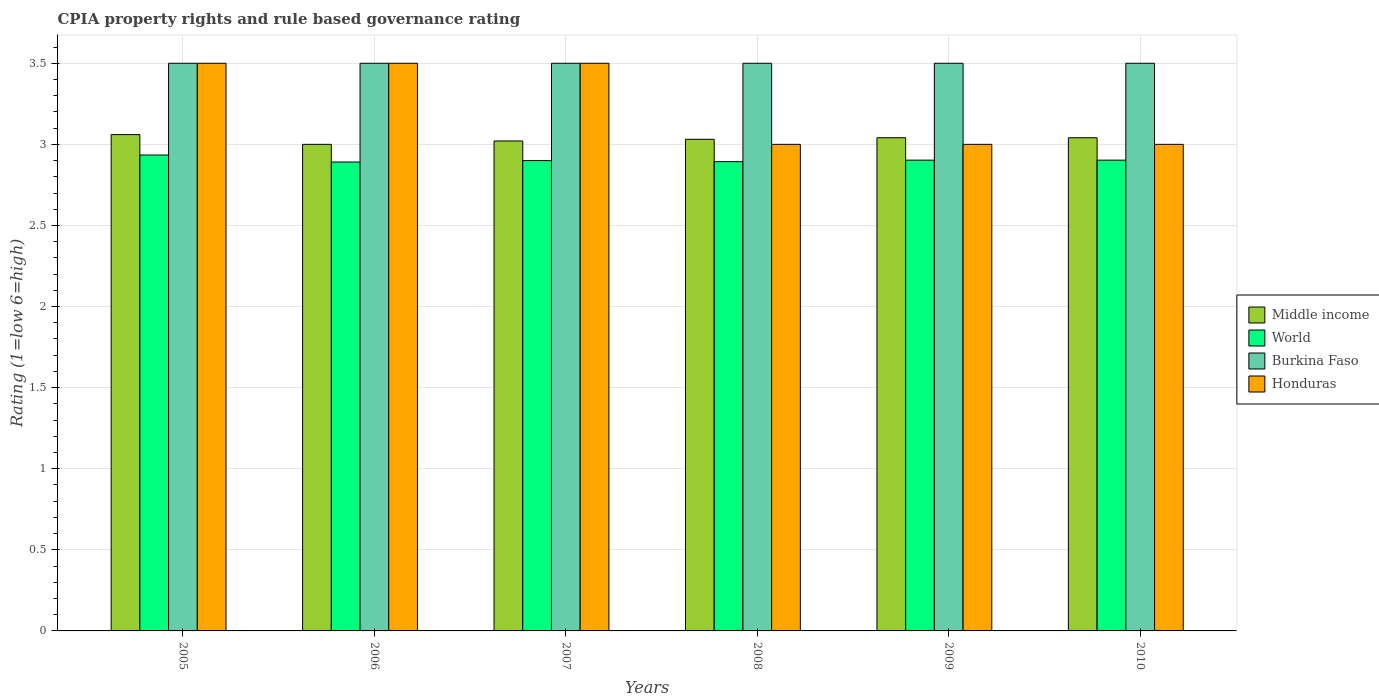How many different coloured bars are there?
Give a very brief answer. 4. Are the number of bars per tick equal to the number of legend labels?
Your answer should be compact. Yes. Are the number of bars on each tick of the X-axis equal?
Your answer should be very brief. Yes. How many bars are there on the 6th tick from the left?
Keep it short and to the point. 4. What is the total CPIA rating in World in the graph?
Your answer should be compact. 17.42. What is the difference between the CPIA rating in Middle income in 2008 and that in 2010?
Offer a very short reply. -0.01. What is the difference between the CPIA rating in Middle income in 2008 and the CPIA rating in Honduras in 2006?
Keep it short and to the point. -0.47. In the year 2009, what is the difference between the CPIA rating in Honduras and CPIA rating in World?
Keep it short and to the point. 0.1. Is the difference between the CPIA rating in Honduras in 2007 and 2008 greater than the difference between the CPIA rating in World in 2007 and 2008?
Provide a short and direct response. Yes. What is the difference between the highest and the second highest CPIA rating in World?
Your response must be concise. 0.03. Is the sum of the CPIA rating in Burkina Faso in 2006 and 2009 greater than the maximum CPIA rating in World across all years?
Provide a succinct answer. Yes. Is it the case that in every year, the sum of the CPIA rating in Honduras and CPIA rating in Burkina Faso is greater than the sum of CPIA rating in World and CPIA rating in Middle income?
Keep it short and to the point. Yes. What does the 3rd bar from the left in 2010 represents?
Your answer should be very brief. Burkina Faso. How many years are there in the graph?
Provide a succinct answer. 6. What is the difference between two consecutive major ticks on the Y-axis?
Ensure brevity in your answer.  0.5. Are the values on the major ticks of Y-axis written in scientific E-notation?
Offer a terse response. No. Where does the legend appear in the graph?
Give a very brief answer. Center right. How many legend labels are there?
Your answer should be compact. 4. What is the title of the graph?
Provide a short and direct response. CPIA property rights and rule based governance rating. What is the Rating (1=low 6=high) of Middle income in 2005?
Provide a short and direct response. 3.06. What is the Rating (1=low 6=high) of World in 2005?
Your answer should be compact. 2.93. What is the Rating (1=low 6=high) in World in 2006?
Give a very brief answer. 2.89. What is the Rating (1=low 6=high) in Burkina Faso in 2006?
Provide a succinct answer. 3.5. What is the Rating (1=low 6=high) in Honduras in 2006?
Keep it short and to the point. 3.5. What is the Rating (1=low 6=high) of Middle income in 2007?
Your response must be concise. 3.02. What is the Rating (1=low 6=high) of World in 2007?
Offer a very short reply. 2.9. What is the Rating (1=low 6=high) of Honduras in 2007?
Provide a succinct answer. 3.5. What is the Rating (1=low 6=high) of Middle income in 2008?
Your answer should be very brief. 3.03. What is the Rating (1=low 6=high) of World in 2008?
Ensure brevity in your answer.  2.89. What is the Rating (1=low 6=high) of Burkina Faso in 2008?
Your answer should be very brief. 3.5. What is the Rating (1=low 6=high) of Honduras in 2008?
Offer a very short reply. 3. What is the Rating (1=low 6=high) in Middle income in 2009?
Make the answer very short. 3.04. What is the Rating (1=low 6=high) in World in 2009?
Provide a succinct answer. 2.9. What is the Rating (1=low 6=high) in Burkina Faso in 2009?
Make the answer very short. 3.5. What is the Rating (1=low 6=high) in Middle income in 2010?
Your answer should be compact. 3.04. What is the Rating (1=low 6=high) in World in 2010?
Make the answer very short. 2.9. What is the Rating (1=low 6=high) of Honduras in 2010?
Your response must be concise. 3. Across all years, what is the maximum Rating (1=low 6=high) of Middle income?
Your answer should be very brief. 3.06. Across all years, what is the maximum Rating (1=low 6=high) of World?
Give a very brief answer. 2.93. Across all years, what is the maximum Rating (1=low 6=high) in Burkina Faso?
Your response must be concise. 3.5. Across all years, what is the minimum Rating (1=low 6=high) of Middle income?
Your answer should be compact. 3. Across all years, what is the minimum Rating (1=low 6=high) of World?
Give a very brief answer. 2.89. What is the total Rating (1=low 6=high) in Middle income in the graph?
Make the answer very short. 18.19. What is the total Rating (1=low 6=high) of World in the graph?
Offer a very short reply. 17.42. What is the total Rating (1=low 6=high) of Burkina Faso in the graph?
Your response must be concise. 21. What is the difference between the Rating (1=low 6=high) of Middle income in 2005 and that in 2006?
Your answer should be very brief. 0.06. What is the difference between the Rating (1=low 6=high) in World in 2005 and that in 2006?
Keep it short and to the point. 0.04. What is the difference between the Rating (1=low 6=high) in Burkina Faso in 2005 and that in 2006?
Ensure brevity in your answer.  0. What is the difference between the Rating (1=low 6=high) of Honduras in 2005 and that in 2006?
Offer a terse response. 0. What is the difference between the Rating (1=low 6=high) of Middle income in 2005 and that in 2007?
Your answer should be very brief. 0.04. What is the difference between the Rating (1=low 6=high) in World in 2005 and that in 2007?
Give a very brief answer. 0.03. What is the difference between the Rating (1=low 6=high) of Burkina Faso in 2005 and that in 2007?
Keep it short and to the point. 0. What is the difference between the Rating (1=low 6=high) of Honduras in 2005 and that in 2007?
Provide a succinct answer. 0. What is the difference between the Rating (1=low 6=high) in Middle income in 2005 and that in 2008?
Offer a very short reply. 0.03. What is the difference between the Rating (1=low 6=high) of World in 2005 and that in 2008?
Your response must be concise. 0.04. What is the difference between the Rating (1=low 6=high) of Middle income in 2005 and that in 2009?
Your answer should be compact. 0.02. What is the difference between the Rating (1=low 6=high) of World in 2005 and that in 2009?
Ensure brevity in your answer.  0.03. What is the difference between the Rating (1=low 6=high) in Middle income in 2005 and that in 2010?
Provide a short and direct response. 0.02. What is the difference between the Rating (1=low 6=high) in World in 2005 and that in 2010?
Give a very brief answer. 0.03. What is the difference between the Rating (1=low 6=high) in Burkina Faso in 2005 and that in 2010?
Offer a terse response. 0. What is the difference between the Rating (1=low 6=high) in Middle income in 2006 and that in 2007?
Your answer should be compact. -0.02. What is the difference between the Rating (1=low 6=high) of World in 2006 and that in 2007?
Your answer should be very brief. -0.01. What is the difference between the Rating (1=low 6=high) in Burkina Faso in 2006 and that in 2007?
Provide a succinct answer. 0. What is the difference between the Rating (1=low 6=high) in Honduras in 2006 and that in 2007?
Your response must be concise. 0. What is the difference between the Rating (1=low 6=high) of Middle income in 2006 and that in 2008?
Offer a very short reply. -0.03. What is the difference between the Rating (1=low 6=high) in World in 2006 and that in 2008?
Make the answer very short. -0. What is the difference between the Rating (1=low 6=high) of Burkina Faso in 2006 and that in 2008?
Your response must be concise. 0. What is the difference between the Rating (1=low 6=high) in Honduras in 2006 and that in 2008?
Your answer should be compact. 0.5. What is the difference between the Rating (1=low 6=high) in Middle income in 2006 and that in 2009?
Provide a succinct answer. -0.04. What is the difference between the Rating (1=low 6=high) of World in 2006 and that in 2009?
Offer a very short reply. -0.01. What is the difference between the Rating (1=low 6=high) in Middle income in 2006 and that in 2010?
Your answer should be compact. -0.04. What is the difference between the Rating (1=low 6=high) of World in 2006 and that in 2010?
Your answer should be very brief. -0.01. What is the difference between the Rating (1=low 6=high) in Middle income in 2007 and that in 2008?
Offer a terse response. -0.01. What is the difference between the Rating (1=low 6=high) in World in 2007 and that in 2008?
Provide a short and direct response. 0.01. What is the difference between the Rating (1=low 6=high) in Burkina Faso in 2007 and that in 2008?
Make the answer very short. 0. What is the difference between the Rating (1=low 6=high) in Middle income in 2007 and that in 2009?
Provide a short and direct response. -0.02. What is the difference between the Rating (1=low 6=high) of World in 2007 and that in 2009?
Provide a succinct answer. -0. What is the difference between the Rating (1=low 6=high) of Honduras in 2007 and that in 2009?
Give a very brief answer. 0.5. What is the difference between the Rating (1=low 6=high) of Middle income in 2007 and that in 2010?
Provide a succinct answer. -0.02. What is the difference between the Rating (1=low 6=high) of World in 2007 and that in 2010?
Offer a very short reply. -0. What is the difference between the Rating (1=low 6=high) of Burkina Faso in 2007 and that in 2010?
Your answer should be compact. 0. What is the difference between the Rating (1=low 6=high) in Honduras in 2007 and that in 2010?
Give a very brief answer. 0.5. What is the difference between the Rating (1=low 6=high) of Middle income in 2008 and that in 2009?
Provide a succinct answer. -0.01. What is the difference between the Rating (1=low 6=high) of World in 2008 and that in 2009?
Your answer should be compact. -0.01. What is the difference between the Rating (1=low 6=high) of Burkina Faso in 2008 and that in 2009?
Make the answer very short. 0. What is the difference between the Rating (1=low 6=high) of Middle income in 2008 and that in 2010?
Ensure brevity in your answer.  -0.01. What is the difference between the Rating (1=low 6=high) in World in 2008 and that in 2010?
Keep it short and to the point. -0.01. What is the difference between the Rating (1=low 6=high) of Burkina Faso in 2008 and that in 2010?
Your answer should be compact. 0. What is the difference between the Rating (1=low 6=high) in Honduras in 2008 and that in 2010?
Give a very brief answer. 0. What is the difference between the Rating (1=low 6=high) in Middle income in 2009 and that in 2010?
Your response must be concise. 0. What is the difference between the Rating (1=low 6=high) in Honduras in 2009 and that in 2010?
Provide a succinct answer. 0. What is the difference between the Rating (1=low 6=high) in Middle income in 2005 and the Rating (1=low 6=high) in World in 2006?
Your answer should be compact. 0.17. What is the difference between the Rating (1=low 6=high) of Middle income in 2005 and the Rating (1=low 6=high) of Burkina Faso in 2006?
Your response must be concise. -0.44. What is the difference between the Rating (1=low 6=high) of Middle income in 2005 and the Rating (1=low 6=high) of Honduras in 2006?
Keep it short and to the point. -0.44. What is the difference between the Rating (1=low 6=high) in World in 2005 and the Rating (1=low 6=high) in Burkina Faso in 2006?
Provide a succinct answer. -0.57. What is the difference between the Rating (1=low 6=high) in World in 2005 and the Rating (1=low 6=high) in Honduras in 2006?
Make the answer very short. -0.57. What is the difference between the Rating (1=low 6=high) of Middle income in 2005 and the Rating (1=low 6=high) of World in 2007?
Keep it short and to the point. 0.16. What is the difference between the Rating (1=low 6=high) of Middle income in 2005 and the Rating (1=low 6=high) of Burkina Faso in 2007?
Give a very brief answer. -0.44. What is the difference between the Rating (1=low 6=high) of Middle income in 2005 and the Rating (1=low 6=high) of Honduras in 2007?
Give a very brief answer. -0.44. What is the difference between the Rating (1=low 6=high) in World in 2005 and the Rating (1=low 6=high) in Burkina Faso in 2007?
Keep it short and to the point. -0.57. What is the difference between the Rating (1=low 6=high) in World in 2005 and the Rating (1=low 6=high) in Honduras in 2007?
Your answer should be compact. -0.57. What is the difference between the Rating (1=low 6=high) in Middle income in 2005 and the Rating (1=low 6=high) in Burkina Faso in 2008?
Offer a terse response. -0.44. What is the difference between the Rating (1=low 6=high) of Middle income in 2005 and the Rating (1=low 6=high) of Honduras in 2008?
Make the answer very short. 0.06. What is the difference between the Rating (1=low 6=high) of World in 2005 and the Rating (1=low 6=high) of Burkina Faso in 2008?
Provide a succinct answer. -0.57. What is the difference between the Rating (1=low 6=high) of World in 2005 and the Rating (1=low 6=high) of Honduras in 2008?
Keep it short and to the point. -0.07. What is the difference between the Rating (1=low 6=high) of Burkina Faso in 2005 and the Rating (1=low 6=high) of Honduras in 2008?
Make the answer very short. 0.5. What is the difference between the Rating (1=low 6=high) in Middle income in 2005 and the Rating (1=low 6=high) in World in 2009?
Make the answer very short. 0.16. What is the difference between the Rating (1=low 6=high) in Middle income in 2005 and the Rating (1=low 6=high) in Burkina Faso in 2009?
Your response must be concise. -0.44. What is the difference between the Rating (1=low 6=high) of World in 2005 and the Rating (1=low 6=high) of Burkina Faso in 2009?
Your response must be concise. -0.57. What is the difference between the Rating (1=low 6=high) of World in 2005 and the Rating (1=low 6=high) of Honduras in 2009?
Offer a very short reply. -0.07. What is the difference between the Rating (1=low 6=high) of Middle income in 2005 and the Rating (1=low 6=high) of World in 2010?
Your response must be concise. 0.16. What is the difference between the Rating (1=low 6=high) in Middle income in 2005 and the Rating (1=low 6=high) in Burkina Faso in 2010?
Provide a succinct answer. -0.44. What is the difference between the Rating (1=low 6=high) in World in 2005 and the Rating (1=low 6=high) in Burkina Faso in 2010?
Keep it short and to the point. -0.57. What is the difference between the Rating (1=low 6=high) in World in 2005 and the Rating (1=low 6=high) in Honduras in 2010?
Make the answer very short. -0.07. What is the difference between the Rating (1=low 6=high) in Burkina Faso in 2005 and the Rating (1=low 6=high) in Honduras in 2010?
Make the answer very short. 0.5. What is the difference between the Rating (1=low 6=high) of World in 2006 and the Rating (1=low 6=high) of Burkina Faso in 2007?
Ensure brevity in your answer.  -0.61. What is the difference between the Rating (1=low 6=high) in World in 2006 and the Rating (1=low 6=high) in Honduras in 2007?
Make the answer very short. -0.61. What is the difference between the Rating (1=low 6=high) of Middle income in 2006 and the Rating (1=low 6=high) of World in 2008?
Provide a short and direct response. 0.11. What is the difference between the Rating (1=low 6=high) of Middle income in 2006 and the Rating (1=low 6=high) of Burkina Faso in 2008?
Make the answer very short. -0.5. What is the difference between the Rating (1=low 6=high) in Middle income in 2006 and the Rating (1=low 6=high) in Honduras in 2008?
Provide a succinct answer. 0. What is the difference between the Rating (1=low 6=high) of World in 2006 and the Rating (1=low 6=high) of Burkina Faso in 2008?
Your answer should be very brief. -0.61. What is the difference between the Rating (1=low 6=high) in World in 2006 and the Rating (1=low 6=high) in Honduras in 2008?
Your response must be concise. -0.11. What is the difference between the Rating (1=low 6=high) of Burkina Faso in 2006 and the Rating (1=low 6=high) of Honduras in 2008?
Offer a very short reply. 0.5. What is the difference between the Rating (1=low 6=high) of Middle income in 2006 and the Rating (1=low 6=high) of World in 2009?
Keep it short and to the point. 0.1. What is the difference between the Rating (1=low 6=high) in Middle income in 2006 and the Rating (1=low 6=high) in Burkina Faso in 2009?
Make the answer very short. -0.5. What is the difference between the Rating (1=low 6=high) in Middle income in 2006 and the Rating (1=low 6=high) in Honduras in 2009?
Provide a succinct answer. 0. What is the difference between the Rating (1=low 6=high) of World in 2006 and the Rating (1=low 6=high) of Burkina Faso in 2009?
Your response must be concise. -0.61. What is the difference between the Rating (1=low 6=high) of World in 2006 and the Rating (1=low 6=high) of Honduras in 2009?
Make the answer very short. -0.11. What is the difference between the Rating (1=low 6=high) of Burkina Faso in 2006 and the Rating (1=low 6=high) of Honduras in 2009?
Provide a succinct answer. 0.5. What is the difference between the Rating (1=low 6=high) in Middle income in 2006 and the Rating (1=low 6=high) in World in 2010?
Ensure brevity in your answer.  0.1. What is the difference between the Rating (1=low 6=high) of Middle income in 2006 and the Rating (1=low 6=high) of Honduras in 2010?
Offer a very short reply. 0. What is the difference between the Rating (1=low 6=high) of World in 2006 and the Rating (1=low 6=high) of Burkina Faso in 2010?
Provide a succinct answer. -0.61. What is the difference between the Rating (1=low 6=high) in World in 2006 and the Rating (1=low 6=high) in Honduras in 2010?
Ensure brevity in your answer.  -0.11. What is the difference between the Rating (1=low 6=high) in Middle income in 2007 and the Rating (1=low 6=high) in World in 2008?
Your answer should be compact. 0.13. What is the difference between the Rating (1=low 6=high) of Middle income in 2007 and the Rating (1=low 6=high) of Burkina Faso in 2008?
Offer a very short reply. -0.48. What is the difference between the Rating (1=low 6=high) in Middle income in 2007 and the Rating (1=low 6=high) in Honduras in 2008?
Provide a succinct answer. 0.02. What is the difference between the Rating (1=low 6=high) in Burkina Faso in 2007 and the Rating (1=low 6=high) in Honduras in 2008?
Offer a very short reply. 0.5. What is the difference between the Rating (1=low 6=high) of Middle income in 2007 and the Rating (1=low 6=high) of World in 2009?
Your response must be concise. 0.12. What is the difference between the Rating (1=low 6=high) in Middle income in 2007 and the Rating (1=low 6=high) in Burkina Faso in 2009?
Your answer should be compact. -0.48. What is the difference between the Rating (1=low 6=high) in Middle income in 2007 and the Rating (1=low 6=high) in Honduras in 2009?
Offer a very short reply. 0.02. What is the difference between the Rating (1=low 6=high) of Burkina Faso in 2007 and the Rating (1=low 6=high) of Honduras in 2009?
Make the answer very short. 0.5. What is the difference between the Rating (1=low 6=high) of Middle income in 2007 and the Rating (1=low 6=high) of World in 2010?
Offer a terse response. 0.12. What is the difference between the Rating (1=low 6=high) in Middle income in 2007 and the Rating (1=low 6=high) in Burkina Faso in 2010?
Your answer should be compact. -0.48. What is the difference between the Rating (1=low 6=high) in Middle income in 2007 and the Rating (1=low 6=high) in Honduras in 2010?
Offer a very short reply. 0.02. What is the difference between the Rating (1=low 6=high) in World in 2007 and the Rating (1=low 6=high) in Burkina Faso in 2010?
Your response must be concise. -0.6. What is the difference between the Rating (1=low 6=high) of Burkina Faso in 2007 and the Rating (1=low 6=high) of Honduras in 2010?
Offer a very short reply. 0.5. What is the difference between the Rating (1=low 6=high) in Middle income in 2008 and the Rating (1=low 6=high) in World in 2009?
Provide a succinct answer. 0.13. What is the difference between the Rating (1=low 6=high) in Middle income in 2008 and the Rating (1=low 6=high) in Burkina Faso in 2009?
Ensure brevity in your answer.  -0.47. What is the difference between the Rating (1=low 6=high) in Middle income in 2008 and the Rating (1=low 6=high) in Honduras in 2009?
Keep it short and to the point. 0.03. What is the difference between the Rating (1=low 6=high) of World in 2008 and the Rating (1=low 6=high) of Burkina Faso in 2009?
Provide a short and direct response. -0.61. What is the difference between the Rating (1=low 6=high) of World in 2008 and the Rating (1=low 6=high) of Honduras in 2009?
Your answer should be very brief. -0.11. What is the difference between the Rating (1=low 6=high) in Middle income in 2008 and the Rating (1=low 6=high) in World in 2010?
Offer a terse response. 0.13. What is the difference between the Rating (1=low 6=high) of Middle income in 2008 and the Rating (1=low 6=high) of Burkina Faso in 2010?
Give a very brief answer. -0.47. What is the difference between the Rating (1=low 6=high) of Middle income in 2008 and the Rating (1=low 6=high) of Honduras in 2010?
Ensure brevity in your answer.  0.03. What is the difference between the Rating (1=low 6=high) of World in 2008 and the Rating (1=low 6=high) of Burkina Faso in 2010?
Offer a very short reply. -0.61. What is the difference between the Rating (1=low 6=high) in World in 2008 and the Rating (1=low 6=high) in Honduras in 2010?
Offer a very short reply. -0.11. What is the difference between the Rating (1=low 6=high) in Burkina Faso in 2008 and the Rating (1=low 6=high) in Honduras in 2010?
Make the answer very short. 0.5. What is the difference between the Rating (1=low 6=high) of Middle income in 2009 and the Rating (1=low 6=high) of World in 2010?
Keep it short and to the point. 0.14. What is the difference between the Rating (1=low 6=high) of Middle income in 2009 and the Rating (1=low 6=high) of Burkina Faso in 2010?
Your answer should be compact. -0.46. What is the difference between the Rating (1=low 6=high) of Middle income in 2009 and the Rating (1=low 6=high) of Honduras in 2010?
Ensure brevity in your answer.  0.04. What is the difference between the Rating (1=low 6=high) of World in 2009 and the Rating (1=low 6=high) of Burkina Faso in 2010?
Offer a terse response. -0.6. What is the difference between the Rating (1=low 6=high) of World in 2009 and the Rating (1=low 6=high) of Honduras in 2010?
Keep it short and to the point. -0.1. What is the difference between the Rating (1=low 6=high) in Burkina Faso in 2009 and the Rating (1=low 6=high) in Honduras in 2010?
Ensure brevity in your answer.  0.5. What is the average Rating (1=low 6=high) of Middle income per year?
Offer a terse response. 3.03. What is the average Rating (1=low 6=high) in World per year?
Keep it short and to the point. 2.9. What is the average Rating (1=low 6=high) in Burkina Faso per year?
Give a very brief answer. 3.5. What is the average Rating (1=low 6=high) of Honduras per year?
Offer a very short reply. 3.25. In the year 2005, what is the difference between the Rating (1=low 6=high) in Middle income and Rating (1=low 6=high) in World?
Give a very brief answer. 0.13. In the year 2005, what is the difference between the Rating (1=low 6=high) of Middle income and Rating (1=low 6=high) of Burkina Faso?
Ensure brevity in your answer.  -0.44. In the year 2005, what is the difference between the Rating (1=low 6=high) of Middle income and Rating (1=low 6=high) of Honduras?
Your answer should be compact. -0.44. In the year 2005, what is the difference between the Rating (1=low 6=high) of World and Rating (1=low 6=high) of Burkina Faso?
Offer a very short reply. -0.57. In the year 2005, what is the difference between the Rating (1=low 6=high) in World and Rating (1=low 6=high) in Honduras?
Keep it short and to the point. -0.57. In the year 2006, what is the difference between the Rating (1=low 6=high) of Middle income and Rating (1=low 6=high) of World?
Give a very brief answer. 0.11. In the year 2006, what is the difference between the Rating (1=low 6=high) of Middle income and Rating (1=low 6=high) of Honduras?
Keep it short and to the point. -0.5. In the year 2006, what is the difference between the Rating (1=low 6=high) of World and Rating (1=low 6=high) of Burkina Faso?
Your answer should be compact. -0.61. In the year 2006, what is the difference between the Rating (1=low 6=high) of World and Rating (1=low 6=high) of Honduras?
Make the answer very short. -0.61. In the year 2007, what is the difference between the Rating (1=low 6=high) of Middle income and Rating (1=low 6=high) of World?
Provide a succinct answer. 0.12. In the year 2007, what is the difference between the Rating (1=low 6=high) of Middle income and Rating (1=low 6=high) of Burkina Faso?
Keep it short and to the point. -0.48. In the year 2007, what is the difference between the Rating (1=low 6=high) of Middle income and Rating (1=low 6=high) of Honduras?
Ensure brevity in your answer.  -0.48. In the year 2007, what is the difference between the Rating (1=low 6=high) in Burkina Faso and Rating (1=low 6=high) in Honduras?
Offer a terse response. 0. In the year 2008, what is the difference between the Rating (1=low 6=high) in Middle income and Rating (1=low 6=high) in World?
Give a very brief answer. 0.14. In the year 2008, what is the difference between the Rating (1=low 6=high) in Middle income and Rating (1=low 6=high) in Burkina Faso?
Offer a terse response. -0.47. In the year 2008, what is the difference between the Rating (1=low 6=high) in Middle income and Rating (1=low 6=high) in Honduras?
Offer a very short reply. 0.03. In the year 2008, what is the difference between the Rating (1=low 6=high) in World and Rating (1=low 6=high) in Burkina Faso?
Provide a succinct answer. -0.61. In the year 2008, what is the difference between the Rating (1=low 6=high) of World and Rating (1=low 6=high) of Honduras?
Your response must be concise. -0.11. In the year 2009, what is the difference between the Rating (1=low 6=high) of Middle income and Rating (1=low 6=high) of World?
Offer a terse response. 0.14. In the year 2009, what is the difference between the Rating (1=low 6=high) in Middle income and Rating (1=low 6=high) in Burkina Faso?
Offer a terse response. -0.46. In the year 2009, what is the difference between the Rating (1=low 6=high) of Middle income and Rating (1=low 6=high) of Honduras?
Ensure brevity in your answer.  0.04. In the year 2009, what is the difference between the Rating (1=low 6=high) of World and Rating (1=low 6=high) of Burkina Faso?
Make the answer very short. -0.6. In the year 2009, what is the difference between the Rating (1=low 6=high) in World and Rating (1=low 6=high) in Honduras?
Your answer should be very brief. -0.1. In the year 2009, what is the difference between the Rating (1=low 6=high) in Burkina Faso and Rating (1=low 6=high) in Honduras?
Make the answer very short. 0.5. In the year 2010, what is the difference between the Rating (1=low 6=high) of Middle income and Rating (1=low 6=high) of World?
Provide a short and direct response. 0.14. In the year 2010, what is the difference between the Rating (1=low 6=high) of Middle income and Rating (1=low 6=high) of Burkina Faso?
Provide a short and direct response. -0.46. In the year 2010, what is the difference between the Rating (1=low 6=high) in Middle income and Rating (1=low 6=high) in Honduras?
Keep it short and to the point. 0.04. In the year 2010, what is the difference between the Rating (1=low 6=high) in World and Rating (1=low 6=high) in Burkina Faso?
Ensure brevity in your answer.  -0.6. In the year 2010, what is the difference between the Rating (1=low 6=high) in World and Rating (1=low 6=high) in Honduras?
Make the answer very short. -0.1. What is the ratio of the Rating (1=low 6=high) of Middle income in 2005 to that in 2006?
Give a very brief answer. 1.02. What is the ratio of the Rating (1=low 6=high) in World in 2005 to that in 2006?
Provide a succinct answer. 1.01. What is the ratio of the Rating (1=low 6=high) of Burkina Faso in 2005 to that in 2006?
Your response must be concise. 1. What is the ratio of the Rating (1=low 6=high) of Honduras in 2005 to that in 2006?
Your response must be concise. 1. What is the ratio of the Rating (1=low 6=high) of Middle income in 2005 to that in 2007?
Your answer should be very brief. 1.01. What is the ratio of the Rating (1=low 6=high) in World in 2005 to that in 2007?
Make the answer very short. 1.01. What is the ratio of the Rating (1=low 6=high) of Burkina Faso in 2005 to that in 2007?
Your response must be concise. 1. What is the ratio of the Rating (1=low 6=high) in Middle income in 2005 to that in 2008?
Your answer should be very brief. 1.01. What is the ratio of the Rating (1=low 6=high) of World in 2005 to that in 2008?
Offer a very short reply. 1.01. What is the ratio of the Rating (1=low 6=high) in Burkina Faso in 2005 to that in 2008?
Make the answer very short. 1. What is the ratio of the Rating (1=low 6=high) in World in 2005 to that in 2009?
Keep it short and to the point. 1.01. What is the ratio of the Rating (1=low 6=high) of Burkina Faso in 2005 to that in 2009?
Make the answer very short. 1. What is the ratio of the Rating (1=low 6=high) of Honduras in 2005 to that in 2009?
Your answer should be compact. 1.17. What is the ratio of the Rating (1=low 6=high) in Middle income in 2005 to that in 2010?
Your answer should be very brief. 1.01. What is the ratio of the Rating (1=low 6=high) in World in 2005 to that in 2010?
Offer a terse response. 1.01. What is the ratio of the Rating (1=low 6=high) in Burkina Faso in 2005 to that in 2010?
Give a very brief answer. 1. What is the ratio of the Rating (1=low 6=high) in Honduras in 2005 to that in 2010?
Give a very brief answer. 1.17. What is the ratio of the Rating (1=low 6=high) in World in 2006 to that in 2007?
Ensure brevity in your answer.  1. What is the ratio of the Rating (1=low 6=high) of Honduras in 2006 to that in 2007?
Your response must be concise. 1. What is the ratio of the Rating (1=low 6=high) in Middle income in 2006 to that in 2008?
Offer a terse response. 0.99. What is the ratio of the Rating (1=low 6=high) of World in 2006 to that in 2008?
Provide a succinct answer. 1. What is the ratio of the Rating (1=low 6=high) in Middle income in 2006 to that in 2009?
Make the answer very short. 0.99. What is the ratio of the Rating (1=low 6=high) in Burkina Faso in 2006 to that in 2009?
Provide a short and direct response. 1. What is the ratio of the Rating (1=low 6=high) of Middle income in 2006 to that in 2010?
Ensure brevity in your answer.  0.99. What is the ratio of the Rating (1=low 6=high) in Burkina Faso in 2006 to that in 2010?
Your response must be concise. 1. What is the ratio of the Rating (1=low 6=high) in Middle income in 2007 to that in 2008?
Give a very brief answer. 1. What is the ratio of the Rating (1=low 6=high) in Burkina Faso in 2007 to that in 2008?
Provide a short and direct response. 1. What is the ratio of the Rating (1=low 6=high) in Middle income in 2008 to that in 2009?
Make the answer very short. 1. What is the ratio of the Rating (1=low 6=high) of Burkina Faso in 2008 to that in 2009?
Provide a short and direct response. 1. What is the ratio of the Rating (1=low 6=high) in World in 2008 to that in 2010?
Offer a very short reply. 1. What is the ratio of the Rating (1=low 6=high) in Burkina Faso in 2008 to that in 2010?
Offer a very short reply. 1. What is the ratio of the Rating (1=low 6=high) in Honduras in 2008 to that in 2010?
Provide a short and direct response. 1. What is the ratio of the Rating (1=low 6=high) of Middle income in 2009 to that in 2010?
Make the answer very short. 1. What is the ratio of the Rating (1=low 6=high) of World in 2009 to that in 2010?
Ensure brevity in your answer.  1. What is the ratio of the Rating (1=low 6=high) in Burkina Faso in 2009 to that in 2010?
Give a very brief answer. 1. What is the ratio of the Rating (1=low 6=high) in Honduras in 2009 to that in 2010?
Provide a succinct answer. 1. What is the difference between the highest and the second highest Rating (1=low 6=high) in Middle income?
Give a very brief answer. 0.02. What is the difference between the highest and the second highest Rating (1=low 6=high) in World?
Give a very brief answer. 0.03. What is the difference between the highest and the lowest Rating (1=low 6=high) in World?
Ensure brevity in your answer.  0.04. What is the difference between the highest and the lowest Rating (1=low 6=high) in Burkina Faso?
Provide a succinct answer. 0. What is the difference between the highest and the lowest Rating (1=low 6=high) of Honduras?
Keep it short and to the point. 0.5. 